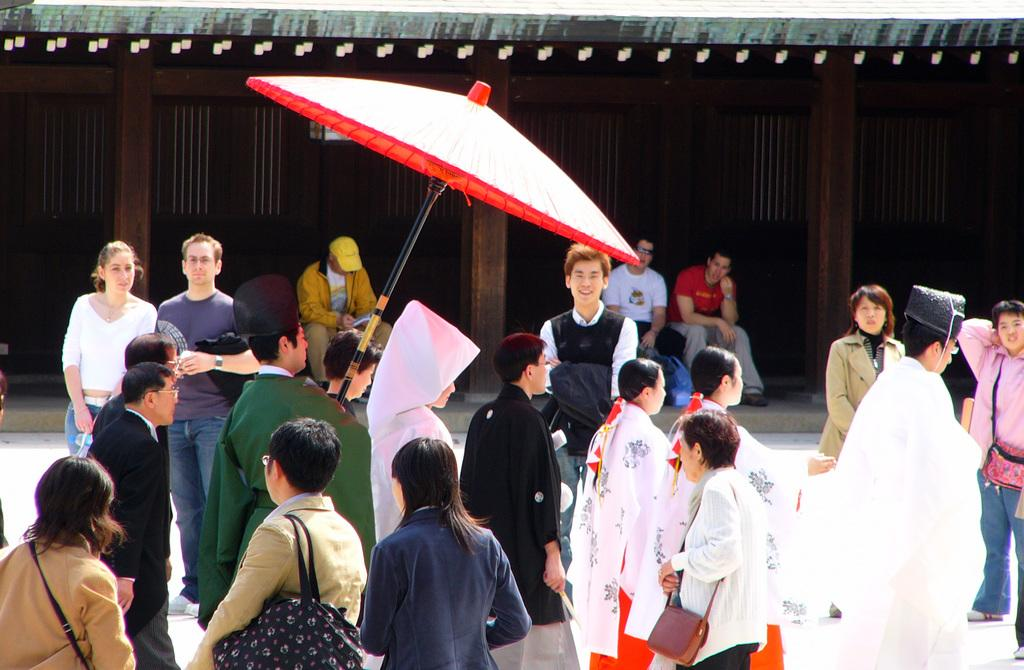How many people are in the image? There are people in the image. What object can be seen in the image that is used for protection from the rain? There is an umbrella in the image. What other objects can be seen in the image besides the umbrella? There are other objects in the image. What can be seen in the background of the image? There is a building in the background of the image. Can you describe the people in the background of the image? There are two people sitting on a bench in the center of the background. What type of toothpaste is the person using in the image? There is no toothpaste present in the image. What fictional character is the person reading about in the image? There is no book or reading material present in the image, so it is not possible to determine if someone is reading about a fictional character. 